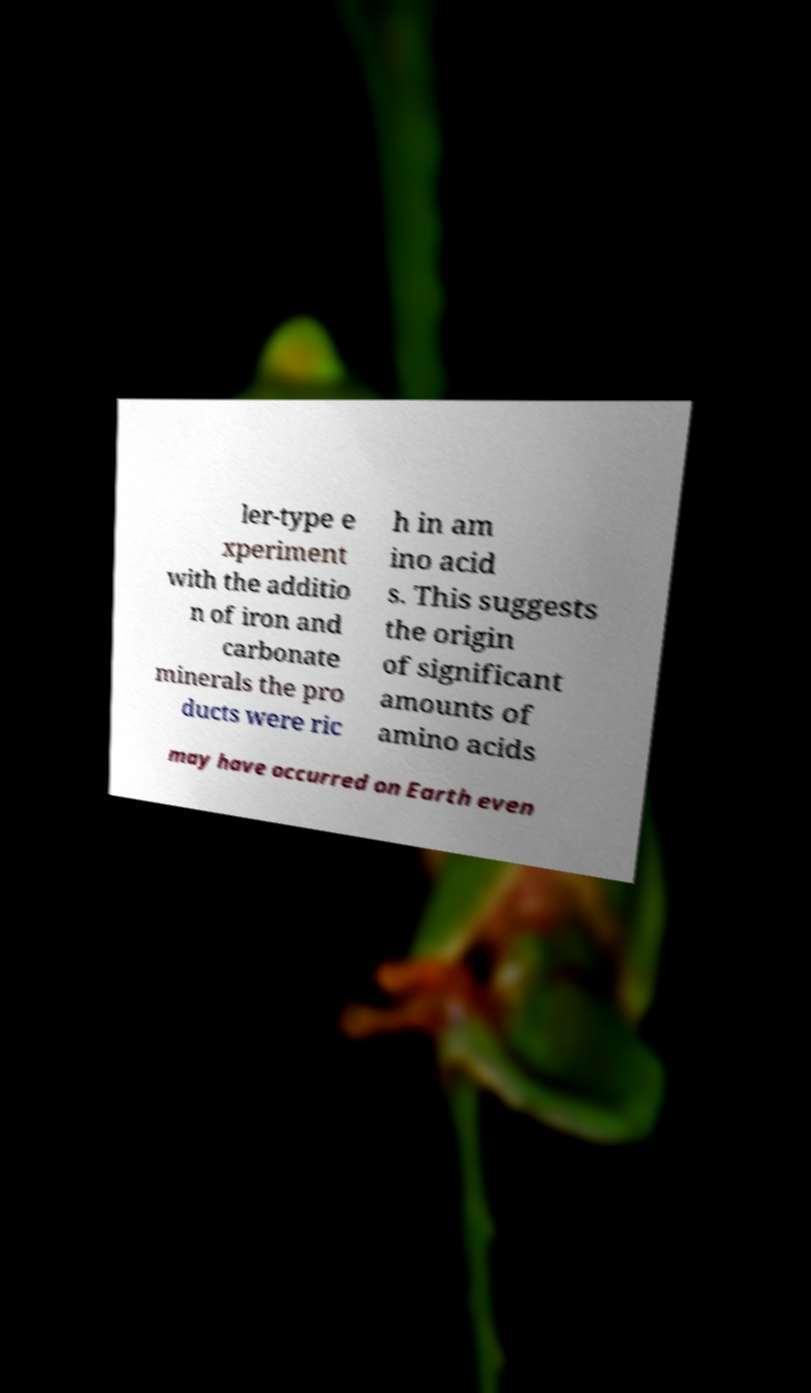What messages or text are displayed in this image? I need them in a readable, typed format. ler-type e xperiment with the additio n of iron and carbonate minerals the pro ducts were ric h in am ino acid s. This suggests the origin of significant amounts of amino acids may have occurred on Earth even 